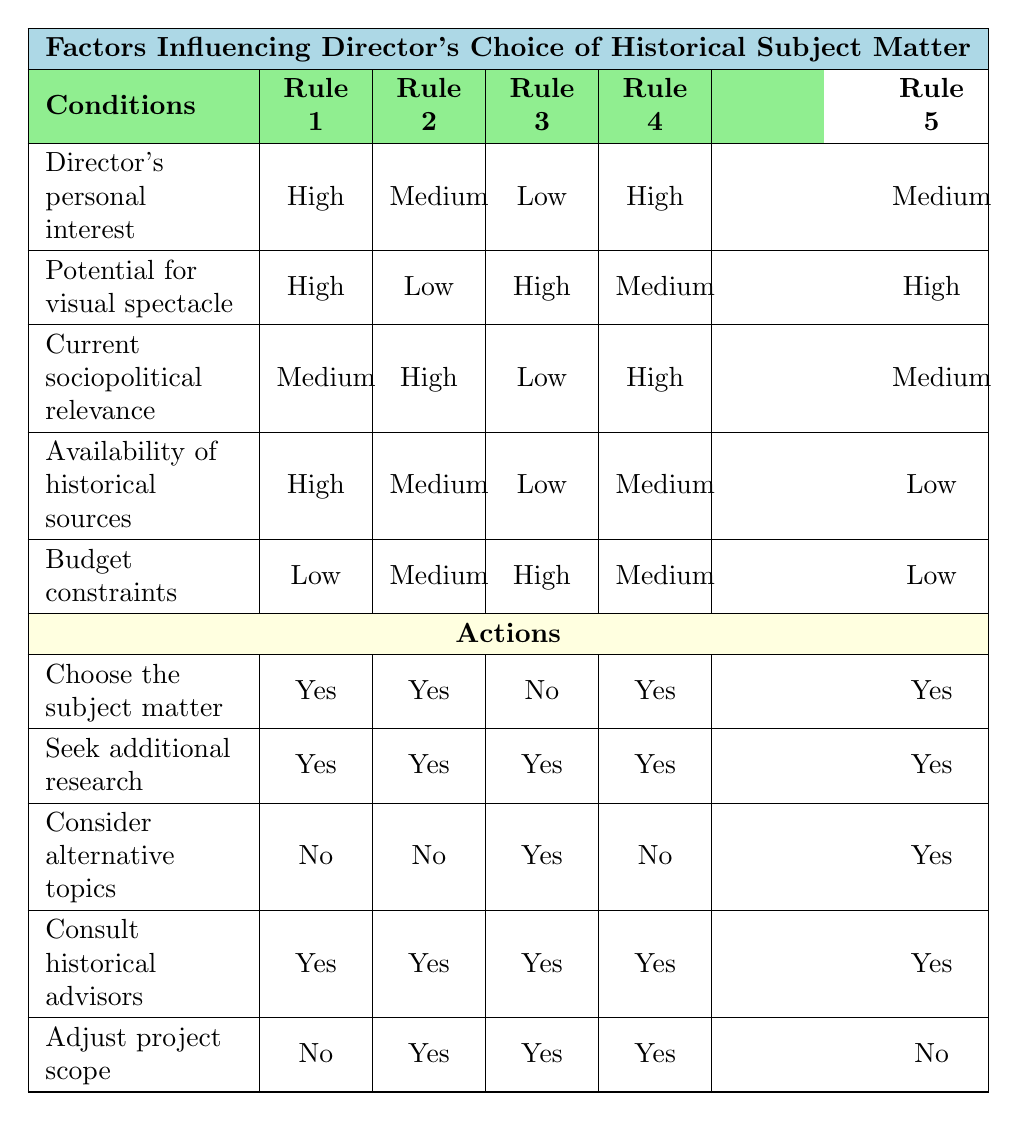What factors influence a director's choice of historical subject matter when their interest is high? Referring to Rule 1 and Rule 4, both indicate a high personal interest in the historical period results in choosing the subject matter. Therefore, the conditions of high interest and their relation to multiple action possibilities lead to the conclusion that such interest strongly influences their choice.
Answer: Yes Is the potential for visual spectacle always a deciding factor in choosing subject matter? Analyzing the rules, in Rule 2 and Rule 3 where the potential for visual spectacle is low, the directors still choose the subject matter, indicating that there's no strict requirement for visual spectacle to be high for a choice to be made.
Answer: No What is the common action taken when a director has low availability of historical sources? In both Rule 3 and Rule 5, when availability is low, the actions include seeking additional research and a willingness to consult historical advisors, which occurs regardless of other conditions. The consistent action indicates a common approach in such scenarios.
Answer: Seek additional research and consult historical advisors How many rules allow for the director to adjust the project scope? By examining the table, adjusting the project scope is allowed in Rules 2, 3, and 4, which gives a total of three rules where this action is permitted. This indicates that adjustments in the scope are tied to various combinations of conditions.
Answer: 3 If a director has a medium socio-political relevance and high potential for visual spectacle, what actions do they typically take? Looking at Rule 5, under these conditions, the director chooses the subject matter, seeks additional research, considers alternative topics, and consults historical advisors; the project scope is not adjusted. This reflects a comprehensive engagement with the subject.
Answer: Choose the subject matter, seek additional research, consider alternative topics, consult historical advisors In which rule do directors have a low likelihood of choosing a subject matter while still engaging in other actions? By referring to Rule 3, where the director's interest is low and other relevant parameters also dictate alternatives, it still allows them to seek additional research, consult advisors, and consider different historical topics.
Answer: Rule 3 